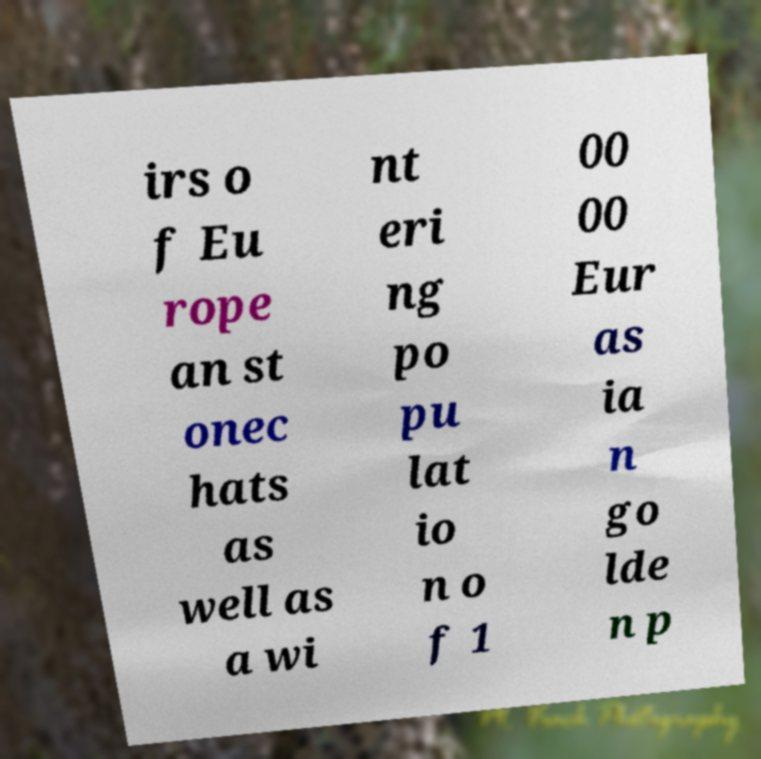Can you read and provide the text displayed in the image?This photo seems to have some interesting text. Can you extract and type it out for me? irs o f Eu rope an st onec hats as well as a wi nt eri ng po pu lat io n o f 1 00 00 Eur as ia n go lde n p 